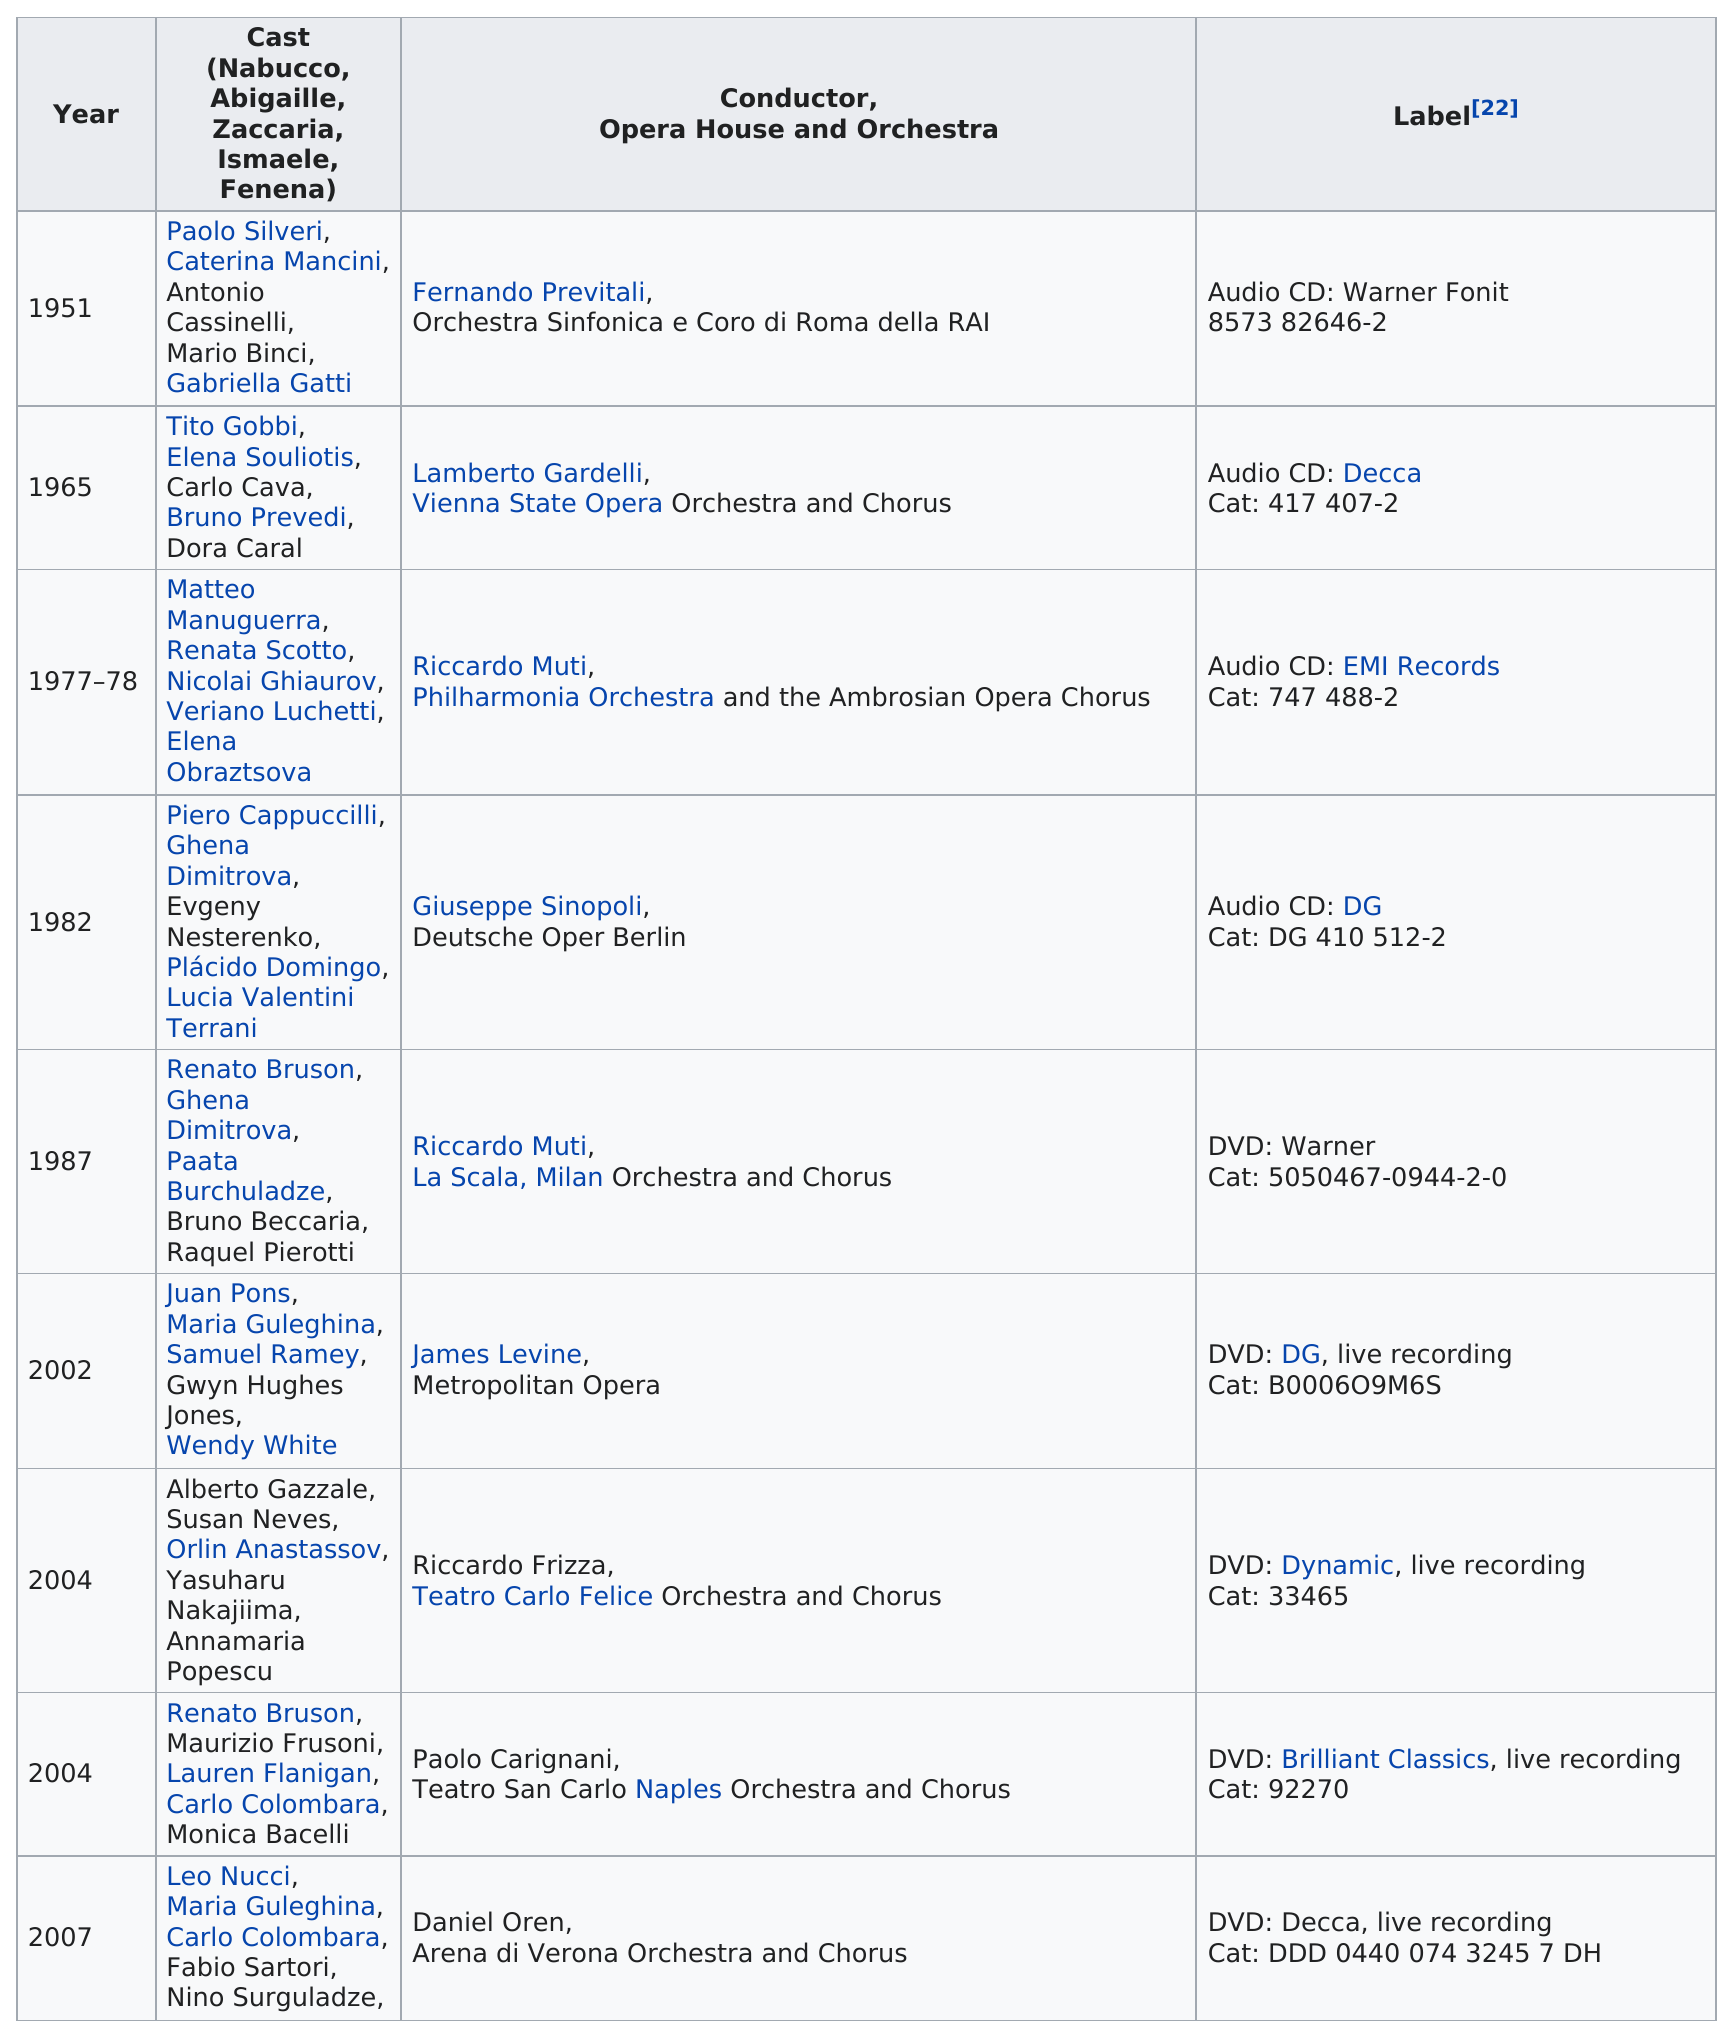Indicate a few pertinent items in this graphic. The recording of Nabucco was made at the Metropolitan Opera in 2002. Nine recordings of "Nabucco" have been made. 